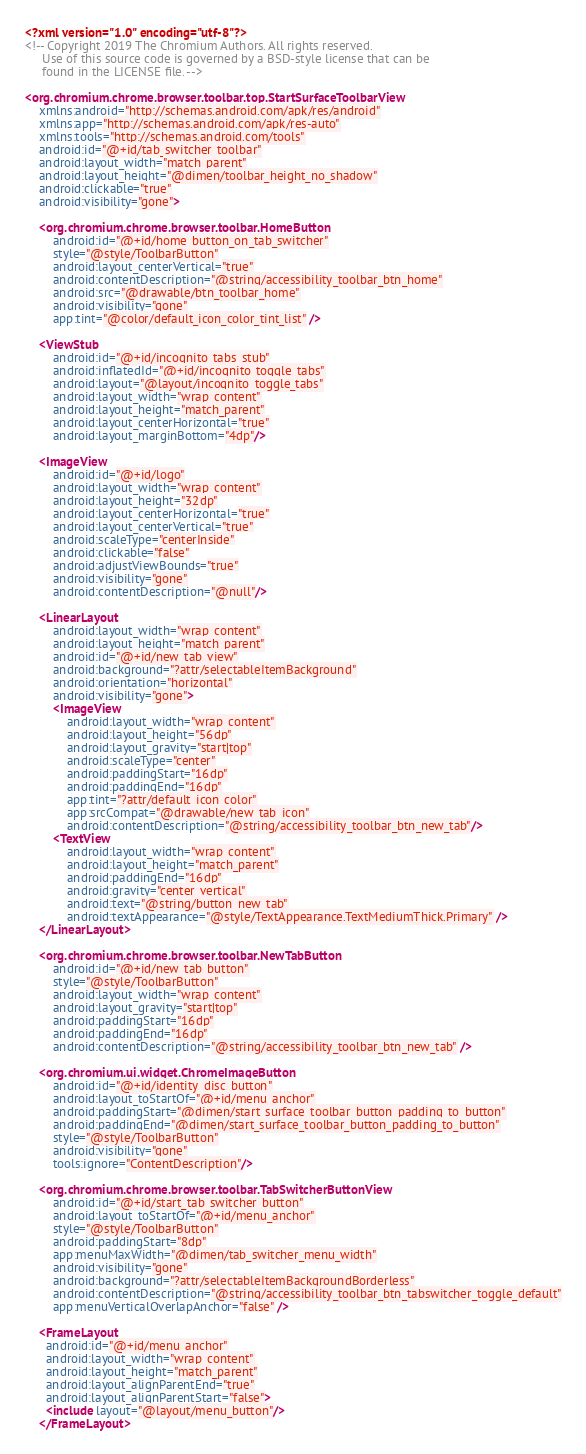Convert code to text. <code><loc_0><loc_0><loc_500><loc_500><_XML_><?xml version="1.0" encoding="utf-8"?>
<!-- Copyright 2019 The Chromium Authors. All rights reserved.
     Use of this source code is governed by a BSD-style license that can be
     found in the LICENSE file. -->

<org.chromium.chrome.browser.toolbar.top.StartSurfaceToolbarView
    xmlns:android="http://schemas.android.com/apk/res/android"
    xmlns:app="http://schemas.android.com/apk/res-auto"
    xmlns:tools="http://schemas.android.com/tools"
    android:id="@+id/tab_switcher_toolbar"
    android:layout_width="match_parent"
    android:layout_height="@dimen/toolbar_height_no_shadow"
    android:clickable="true"
    android:visibility="gone">

    <org.chromium.chrome.browser.toolbar.HomeButton
        android:id="@+id/home_button_on_tab_switcher"
        style="@style/ToolbarButton"
        android:layout_centerVertical="true"
        android:contentDescription="@string/accessibility_toolbar_btn_home"
        android:src="@drawable/btn_toolbar_home"
        android:visibility="gone"
        app:tint="@color/default_icon_color_tint_list" />

    <ViewStub
        android:id="@+id/incognito_tabs_stub"
        android:inflatedId="@+id/incognito_toggle_tabs"
        android:layout="@layout/incognito_toggle_tabs"
        android:layout_width="wrap_content"
        android:layout_height="match_parent"
        android:layout_centerHorizontal="true"
        android:layout_marginBottom="4dp"/>

    <ImageView
        android:id="@+id/logo"
        android:layout_width="wrap_content"
        android:layout_height="32dp"
        android:layout_centerHorizontal="true"
        android:layout_centerVertical="true"
        android:scaleType="centerInside"
        android:clickable="false"
        android:adjustViewBounds="true"
        android:visibility="gone"
        android:contentDescription="@null"/>

    <LinearLayout
        android:layout_width="wrap_content"
        android:layout_height="match_parent"
        android:id="@+id/new_tab_view"
        android:background="?attr/selectableItemBackground"
        android:orientation="horizontal"
        android:visibility="gone">
        <ImageView
            android:layout_width="wrap_content"
            android:layout_height="56dp"
            android:layout_gravity="start|top"
            android:scaleType="center"
            android:paddingStart="16dp"
            android:paddingEnd="16dp"
            app:tint="?attr/default_icon_color"
            app:srcCompat="@drawable/new_tab_icon"
            android:contentDescription="@string/accessibility_toolbar_btn_new_tab"/>
        <TextView
            android:layout_width="wrap_content"
            android:layout_height="match_parent"
            android:paddingEnd="16dp"
            android:gravity="center_vertical"
            android:text="@string/button_new_tab"
            android:textAppearance="@style/TextAppearance.TextMediumThick.Primary" />
    </LinearLayout>

    <org.chromium.chrome.browser.toolbar.NewTabButton
        android:id="@+id/new_tab_button"
        style="@style/ToolbarButton"
        android:layout_width="wrap_content"
        android:layout_gravity="start|top"
        android:paddingStart="16dp"
        android:paddingEnd="16dp"
        android:contentDescription="@string/accessibility_toolbar_btn_new_tab" />

    <org.chromium.ui.widget.ChromeImageButton
        android:id="@+id/identity_disc_button"
        android:layout_toStartOf="@+id/menu_anchor"
        android:paddingStart="@dimen/start_surface_toolbar_button_padding_to_button"
        android:paddingEnd="@dimen/start_surface_toolbar_button_padding_to_button"
        style="@style/ToolbarButton"
        android:visibility="gone"
        tools:ignore="ContentDescription"/>

    <org.chromium.chrome.browser.toolbar.TabSwitcherButtonView
        android:id="@+id/start_tab_switcher_button"
        android:layout_toStartOf="@+id/menu_anchor"
        style="@style/ToolbarButton"
        android:paddingStart="8dp"
        app:menuMaxWidth="@dimen/tab_switcher_menu_width"
        android:visibility="gone"
        android:background="?attr/selectableItemBackgroundBorderless"
        android:contentDescription="@string/accessibility_toolbar_btn_tabswitcher_toggle_default"
        app:menuVerticalOverlapAnchor="false" />

    <FrameLayout
      android:id="@+id/menu_anchor"
      android:layout_width="wrap_content"
      android:layout_height="match_parent"
      android:layout_alignParentEnd="true"
      android:layout_alignParentStart="false">
      <include layout="@layout/menu_button"/>
    </FrameLayout>
</code> 